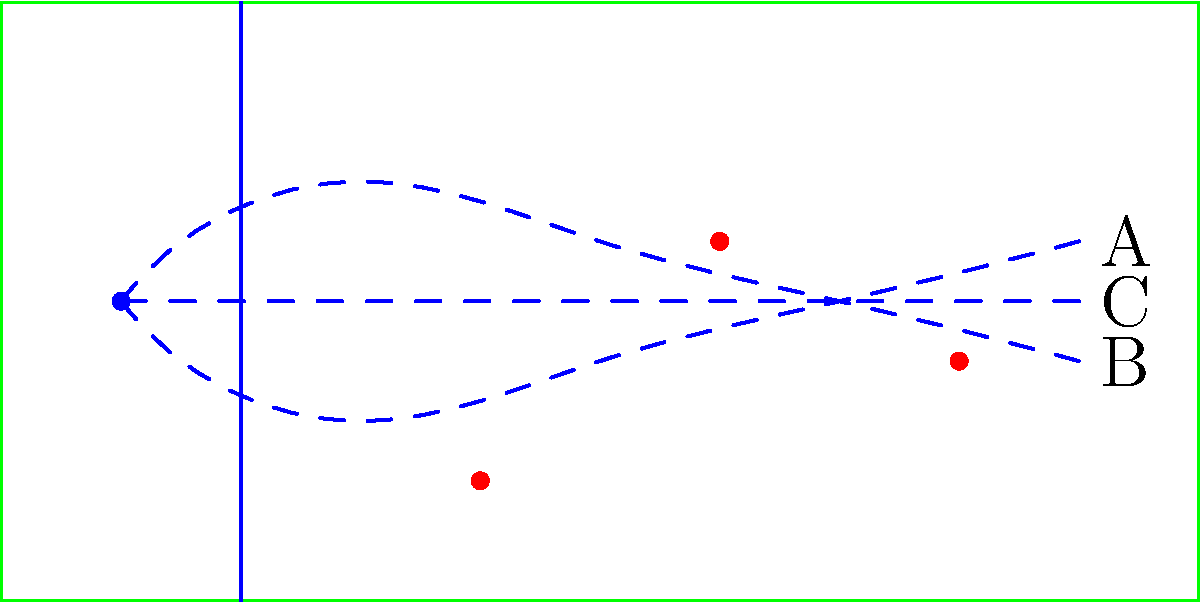Based on the diagram showing potential paths for a running back through the offensive line, which trajectory (A, B, or C) is most likely to result in the longest gain, considering the positions of the defenders (red dots)? To determine the best path for the running back, we need to analyze each trajectory in relation to the defenders' positions:

1. Path A (top curve):
   - Avoids the first defender at (40,10)
   - Passes close to the second defender at (60,30)
   - Ends furthest from the third defender at (80,20)

2. Path B (bottom curve):
   - Passes close to the first defender at (40,10)
   - Avoids the second defender at (60,30)
   - Ends closest to the third defender at (80,20)

3. Path C (middle straight line):
   - Passes between all defenders
   - Maintains a consistent distance from all defenders

Analyzing these paths:
- Path A provides good initial evasion but brings the runner close to the second defender.
- Path B has early risk but good mid-field evasion, ending with potential tackle risk.
- Path C offers a balanced approach, keeping equal distance from all defenders.

In football strategy, maintaining options and avoiding close encounters with defenders is crucial. Path C provides the best balance of these factors:
1. It keeps the runner equidistant from all defenders, making it harder for any single defender to make a play.
2. It provides the straightest route, potentially allowing for the highest speed.
3. It offers the most flexibility for last-second adjustments based on defenders' movements.

Therefore, Path C is most likely to result in the longest gain by balancing evasion and direct progression down the field.
Answer: C 